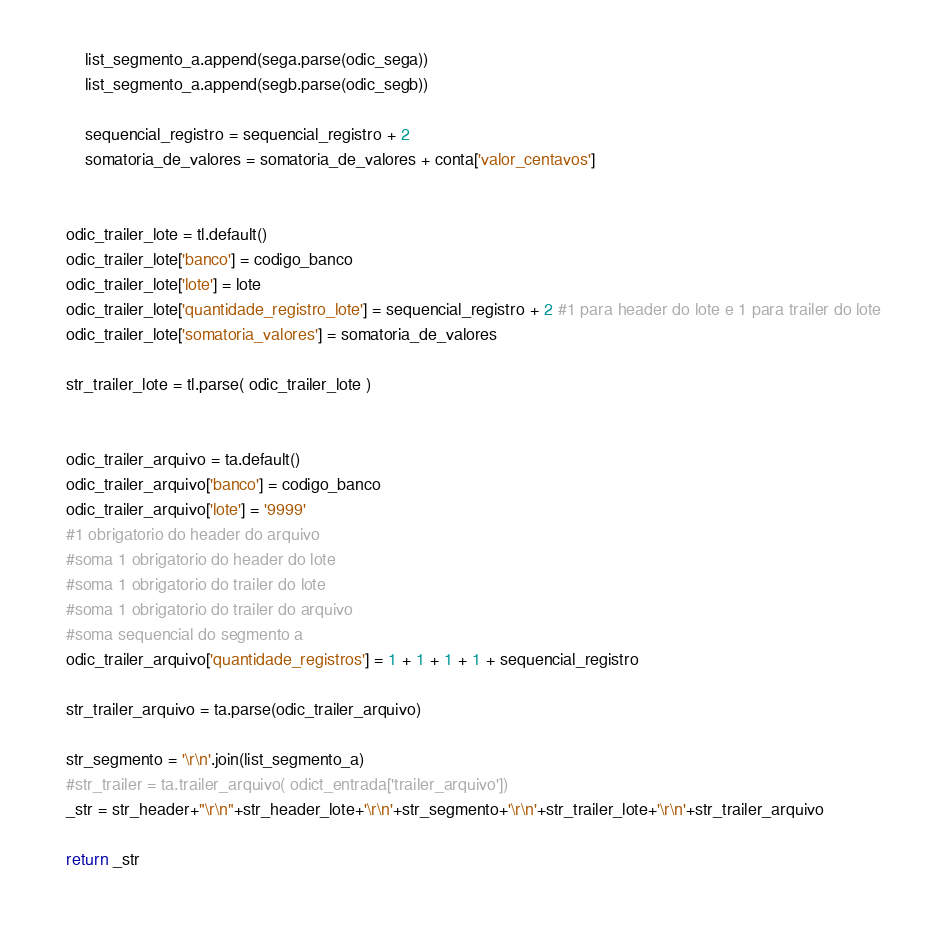<code> <loc_0><loc_0><loc_500><loc_500><_Python_>        list_segmento_a.append(sega.parse(odic_sega))
        list_segmento_a.append(segb.parse(odic_segb))

        sequencial_registro = sequencial_registro + 2
        somatoria_de_valores = somatoria_de_valores + conta['valor_centavos']


    odic_trailer_lote = tl.default()
    odic_trailer_lote['banco'] = codigo_banco
    odic_trailer_lote['lote'] = lote
    odic_trailer_lote['quantidade_registro_lote'] = sequencial_registro + 2 #1 para header do lote e 1 para trailer do lote
    odic_trailer_lote['somatoria_valores'] = somatoria_de_valores

    str_trailer_lote = tl.parse( odic_trailer_lote )


    odic_trailer_arquivo = ta.default()
    odic_trailer_arquivo['banco'] = codigo_banco
    odic_trailer_arquivo['lote'] = '9999'
    #1 obrigatorio do header do arquivo
    #soma 1 obrigatorio do header do lote
    #soma 1 obrigatorio do trailer do lote
    #soma 1 obrigatorio do trailer do arquivo
    #soma sequencial do segmento a
    odic_trailer_arquivo['quantidade_registros'] = 1 + 1 + 1 + 1 + sequencial_registro

    str_trailer_arquivo = ta.parse(odic_trailer_arquivo)

    str_segmento = '\r\n'.join(list_segmento_a)
    #str_trailer = ta.trailer_arquivo( odict_entrada['trailer_arquivo'])
    _str = str_header+"\r\n"+str_header_lote+'\r\n'+str_segmento+'\r\n'+str_trailer_lote+'\r\n'+str_trailer_arquivo

    return _str
  
</code> 